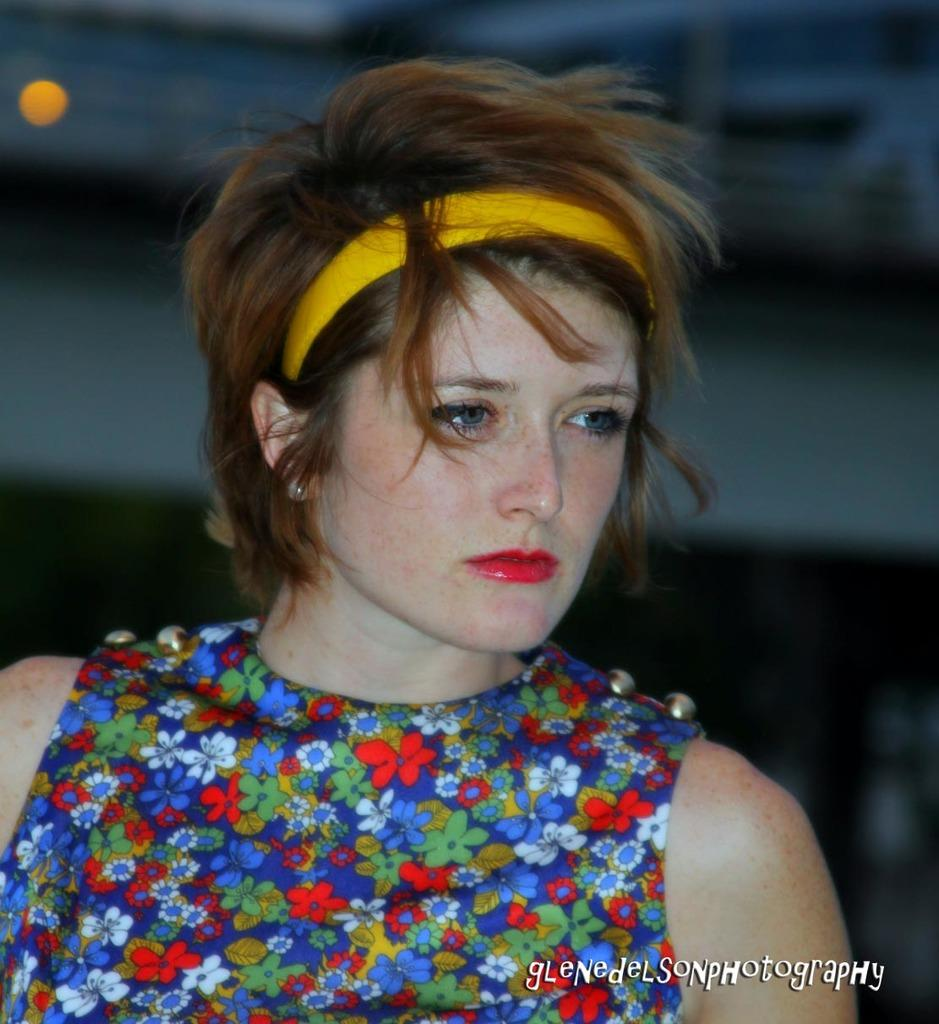Who is the main subject in the image? There is a woman in the image. What is the woman wearing? The woman is wearing a colorful dress. Are there any accessories visible on the woman? Yes, the woman has a hair band. How would you describe the background of the image? The background of the image appears blurry. What type of flowers can be seen growing in the woman's hair in the image? There are no flowers visible in the woman's hair in the image. Is the woman in motion or standing still in the image? The image does not provide information about the woman's motion, but she appears to be standing still. 